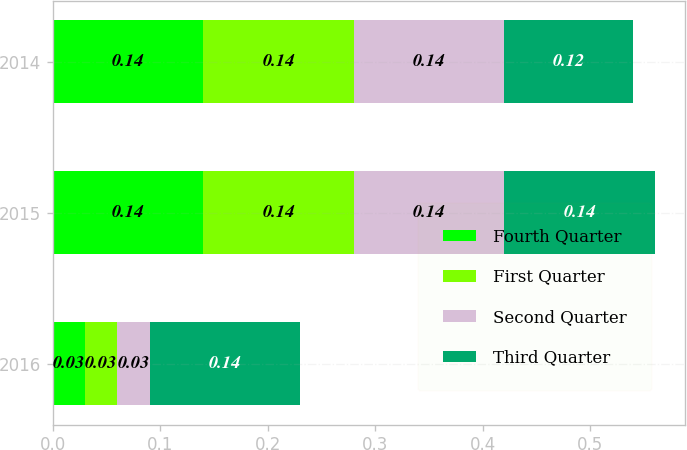<chart> <loc_0><loc_0><loc_500><loc_500><stacked_bar_chart><ecel><fcel>2016<fcel>2015<fcel>2014<nl><fcel>Fourth Quarter<fcel>0.03<fcel>0.14<fcel>0.14<nl><fcel>First Quarter<fcel>0.03<fcel>0.14<fcel>0.14<nl><fcel>Second Quarter<fcel>0.03<fcel>0.14<fcel>0.14<nl><fcel>Third Quarter<fcel>0.14<fcel>0.14<fcel>0.12<nl></chart> 